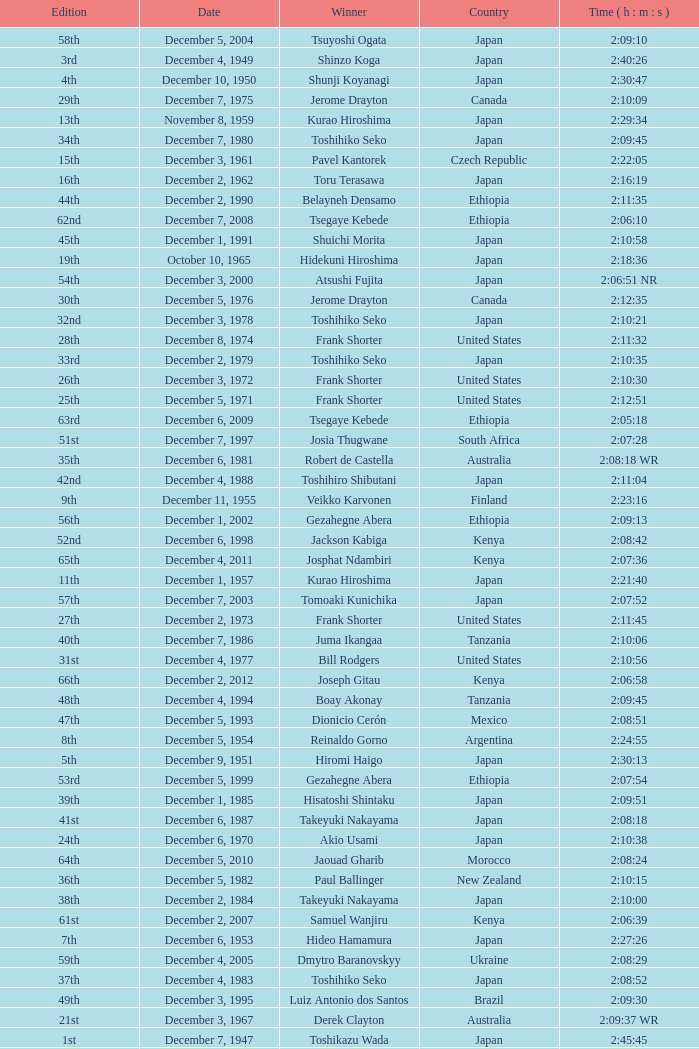What was the nationality of the winner for the 20th Edition? New Zealand. 